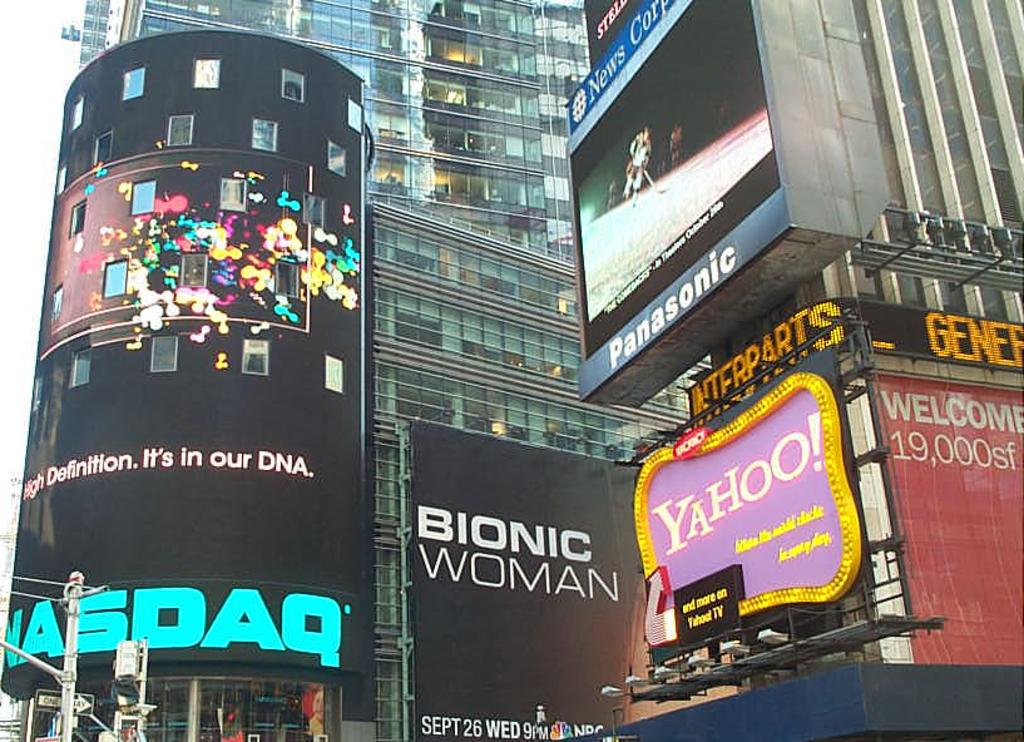What type of structures can be seen in the image? There are buildings in the image. What decorative elements are present in the image? There are banners in the image. What are the banners attached to? The banners are attached to poles in the image. What type of illumination is visible in the image? There are lights in the image. What type of shape can be seen in the harbor in the image? There is no harbor present in the image, so it is not possible to determine the shape of a harbor. 